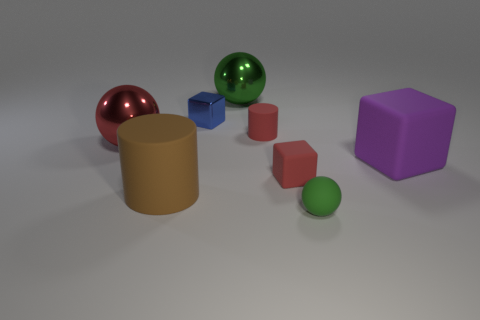Are there any other things that have the same color as the matte ball?
Offer a very short reply. Yes. How many things are either big cyan balls or blue metal cubes?
Offer a terse response. 1. There is a green ball in front of the brown cylinder; is it the same size as the blue object?
Offer a very short reply. Yes. What number of other things are the same size as the green metallic object?
Offer a very short reply. 3. Is there a big cyan object?
Your answer should be compact. No. There is a green sphere behind the rubber cylinder that is on the right side of the big rubber cylinder; what size is it?
Your response must be concise. Large. There is a metal ball behind the tiny blue metal object; is its color the same as the sphere in front of the red shiny object?
Provide a succinct answer. Yes. What color is the tiny rubber thing that is in front of the red ball and behind the large matte cylinder?
Ensure brevity in your answer.  Red. What number of other things are there of the same shape as the blue object?
Keep it short and to the point. 2. What color is the other rubber object that is the same size as the brown thing?
Provide a short and direct response. Purple. 